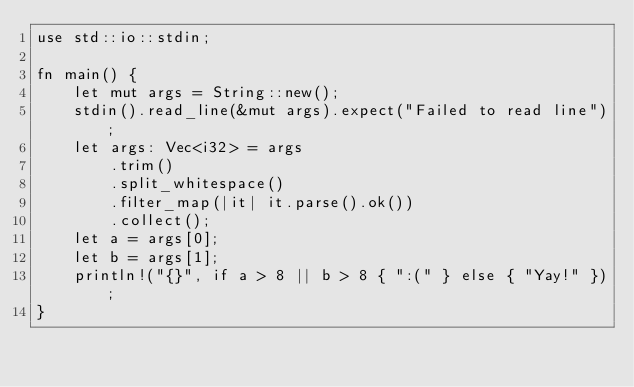Convert code to text. <code><loc_0><loc_0><loc_500><loc_500><_Rust_>use std::io::stdin;

fn main() {
    let mut args = String::new();
    stdin().read_line(&mut args).expect("Failed to read line");
    let args: Vec<i32> = args
        .trim()
        .split_whitespace()
        .filter_map(|it| it.parse().ok())
        .collect();
    let a = args[0];
    let b = args[1];
    println!("{}", if a > 8 || b > 8 { ":(" } else { "Yay!" });
}
</code> 